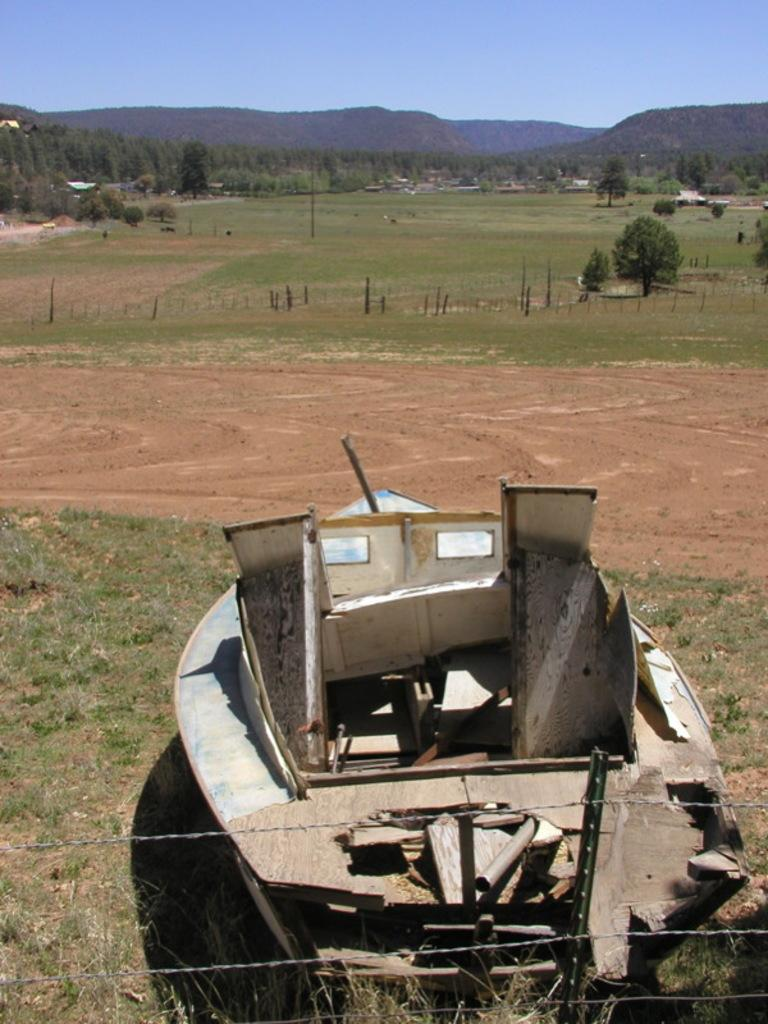What is the main subject of the image? There is a ship on the ground in the image. What type of barrier can be seen in the image? There is fencing in the image. What type of vegetation is present in the image? There are trees and grass in the image. What type of geographical feature is visible in the image? There are mountains in the image. What is the tall, vertical object in the image? There is a pole in the image. What part of the natural environment is visible in the image? The sky is visible in the image. What type of maid can be seen starting a car in the image? There is no maid or car present in the image. 